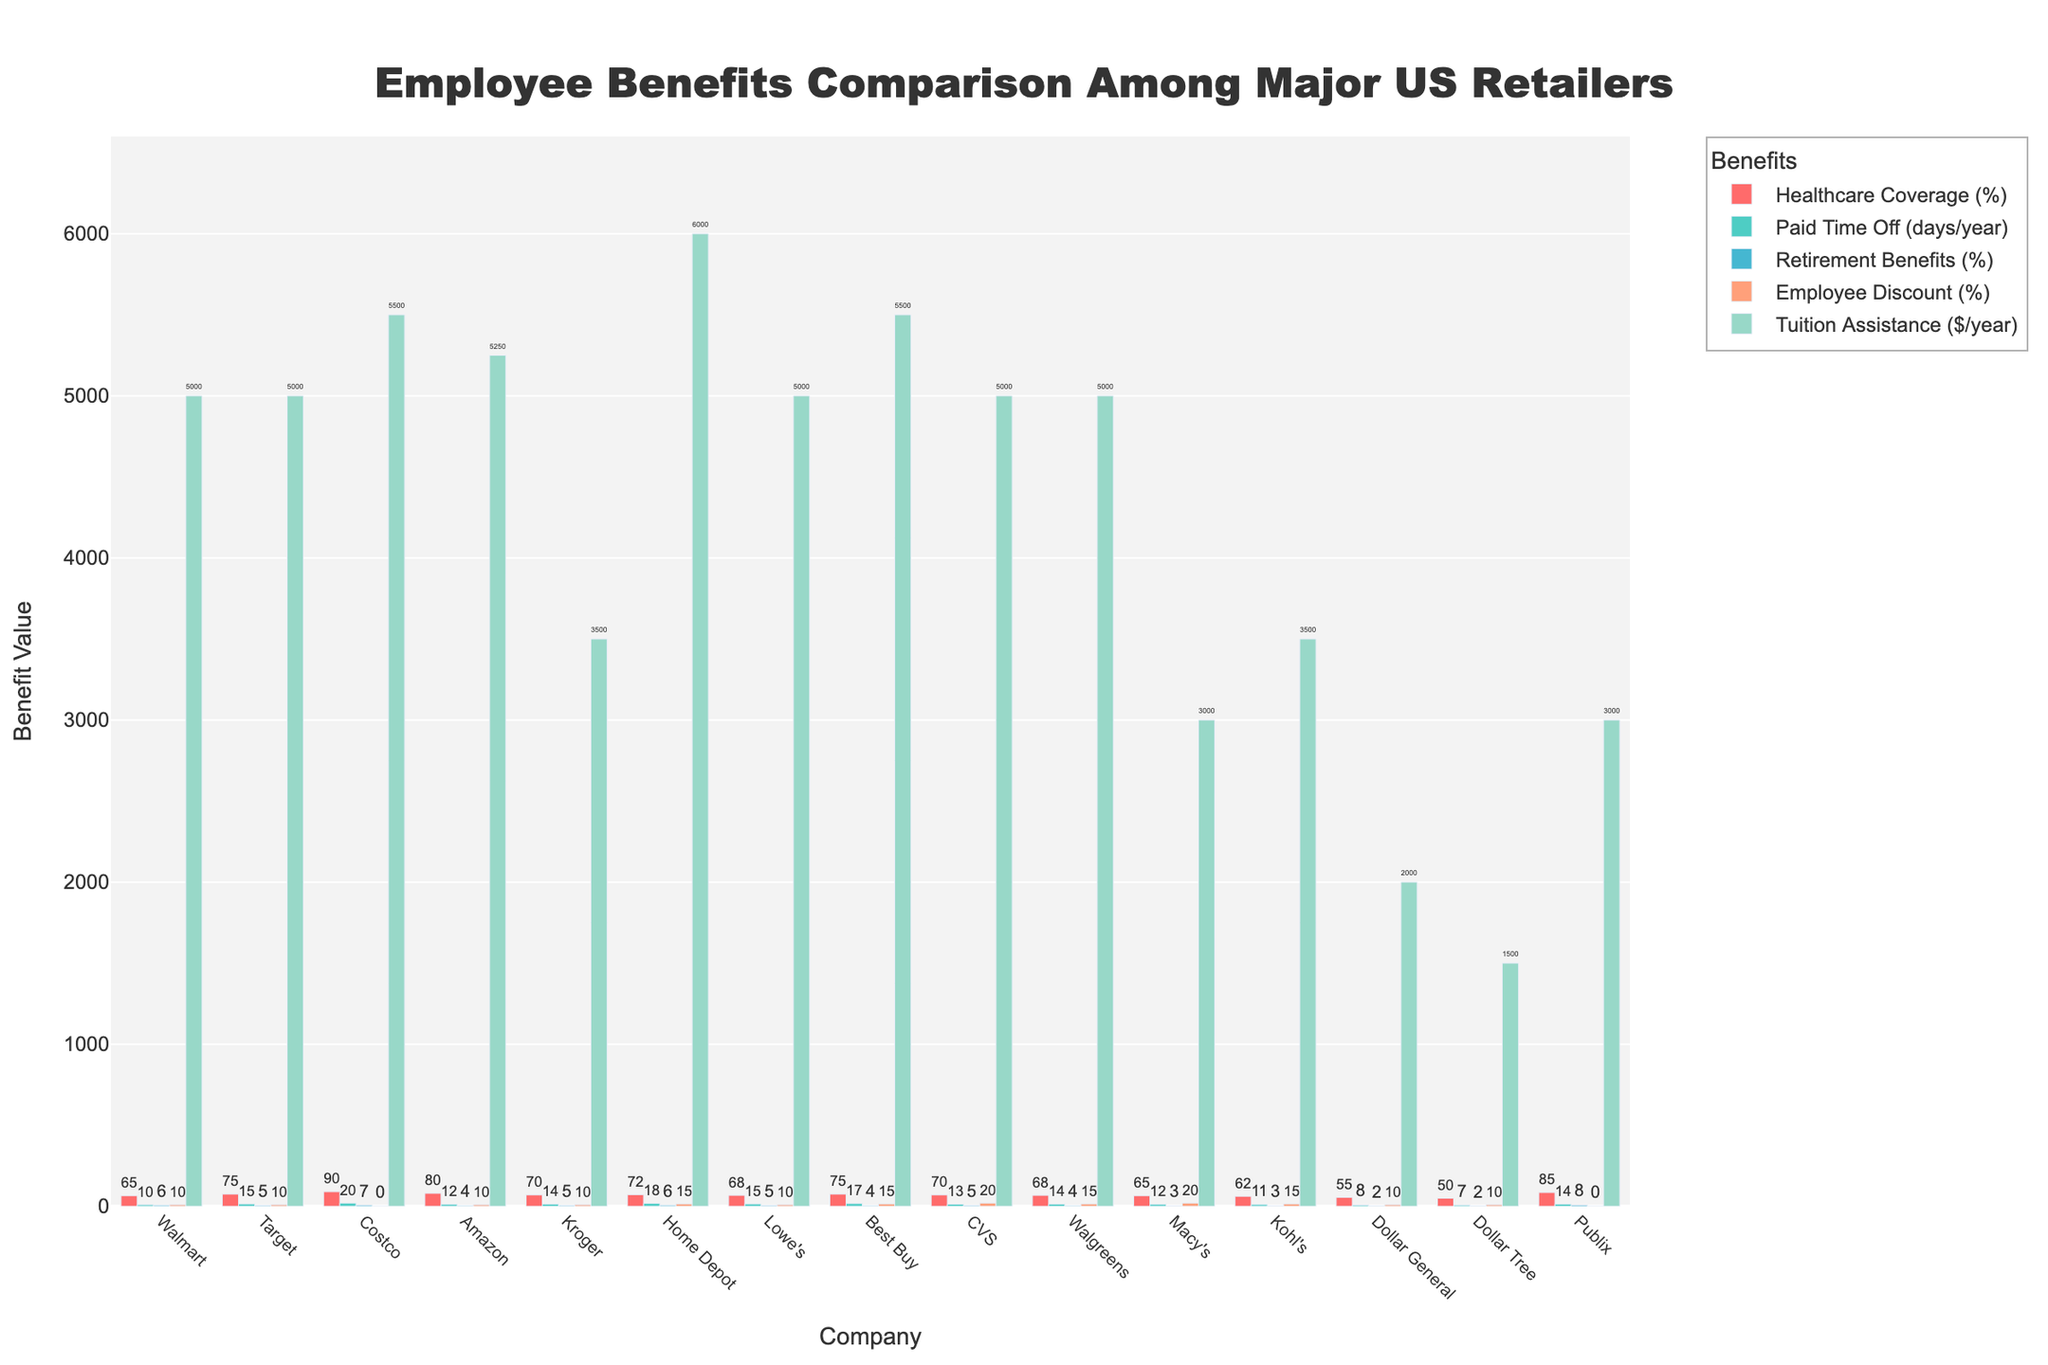What's the company with the highest healthcare coverage? Find the company with the tallest bar in the "Healthcare Coverage (%)" category. Costco has the highest healthcare coverage at 90%.
Answer: Costco Which company offers the most paid time off? Compare the heights of the bars in the "Paid Time Off (days/year)" category to find the tallest one. Costco provides the most paid time off with 20 days per year.
Answer: Costco How does Walmart's retirement benefits compare to Amazon's? Look at the heights of the bars in the "Retirement Benefits (%)" category for both Walmart and Amazon. Walmart offers 6% while Amazon offers 4%, so Walmart offers higher retirement benefits.
Answer: Walmart's are higher Which company has the lowest tuition assistance? Identify the shortest bar in the "Tuition Assistance ($/year)" category. Dollar Tree offers the lowest tuition assistance with $1500 per year.
Answer: Dollar Tree What is the total paid time off for Target, Home Depot, and Best Buy combined? Add the values for "Paid Time Off (days/year)" for Target, Home Depot, and Best Buy. Target (15) + Home Depot (18) + Best Buy (17) = 50 days total.
Answer: 50 days Who offers a 10% employee discount? Look at the companies with a bar height of 10% in the "Employee Discount (%)" category. Walmart, Target, Amazon, Kroger, and Lowe's all offer a 10% employee discount.
Answer: Walmart, Target, Amazon, Kroger, Lowe's Which company has more healthcare coverage: Kroger or Walgreens? Compare the heights of the bars in the "Healthcare Coverage (%)" category for Kroger and Walgreens. Kroger has 70% while Walgreens has 68%.
Answer: Kroger How many companies offer tuition assistance of $5000 or more? Count the number of bars that reach $5000 or more in the "Tuition Assistance ($/year)" category. There are eight companies offering $5000 or more: Walmart, Target, Costco, Amazon, Home Depot, Lowe's, Best Buy, CVS.
Answer: 8 companies Which companies provide more than 70% healthcare coverage? Identify the tall bars in the "Healthcare Coverage (%)" category that exceed 70%. Target, Costco, Amazon, Kroger, Home Depot, Best Buy, and Publix offer more than 70%.
Answer: Target, Costco, Amazon, Kroger, Home Depot, Best Buy, Publix 